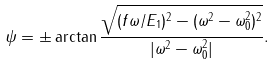<formula> <loc_0><loc_0><loc_500><loc_500>\psi = \pm \arctan \frac { \sqrt { ( f \omega / E _ { 1 } ) ^ { 2 } - ( \omega ^ { 2 } - \omega _ { 0 } ^ { 2 } ) ^ { 2 } } } { | \omega ^ { 2 } - \omega _ { 0 } ^ { 2 } | } .</formula> 